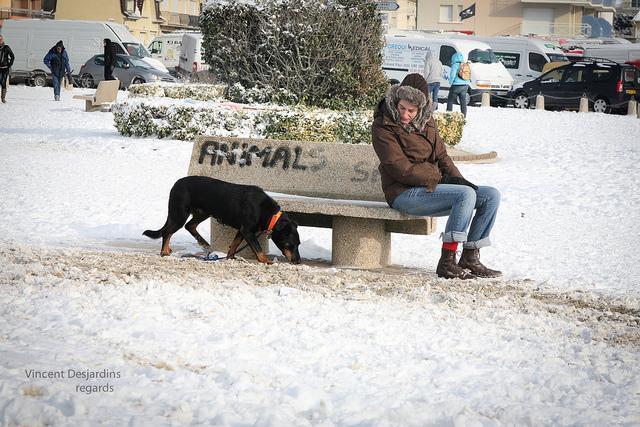How many trucks can be seen?
Give a very brief answer. 3. How many dogs are there?
Give a very brief answer. 1. How many apple iphones are there?
Give a very brief answer. 0. 